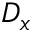Convert formula to latex. <formula><loc_0><loc_0><loc_500><loc_500>D _ { x }</formula> 